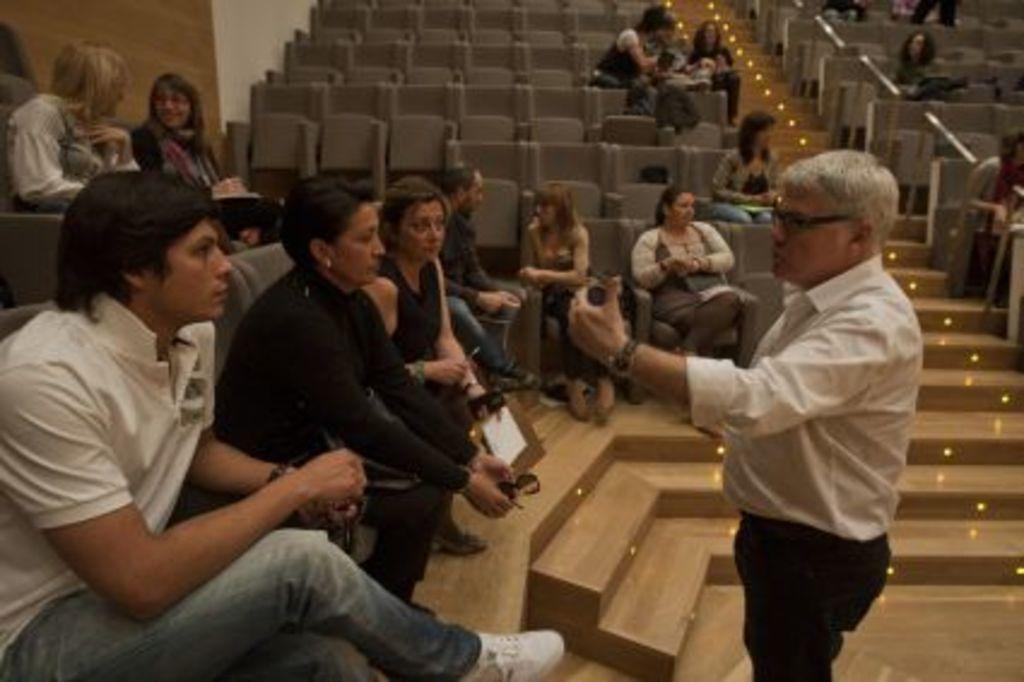Please provide a concise description of this image. In the image we can see there are people sitting on the chair and there is a man standing in front of them. There are lightings on the stairs. 